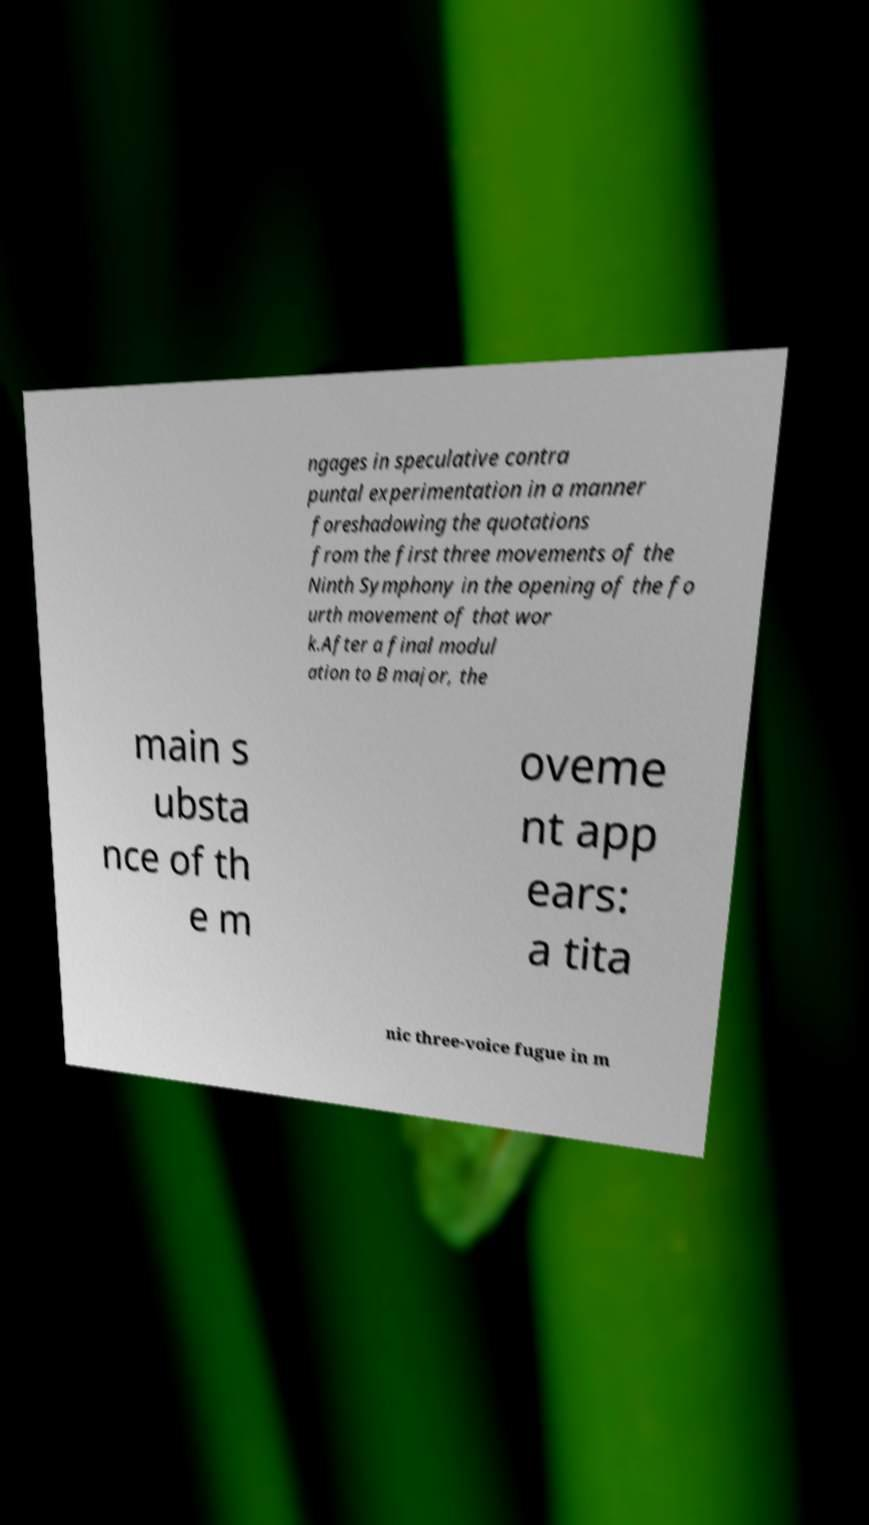Could you assist in decoding the text presented in this image and type it out clearly? ngages in speculative contra puntal experimentation in a manner foreshadowing the quotations from the first three movements of the Ninth Symphony in the opening of the fo urth movement of that wor k.After a final modul ation to B major, the main s ubsta nce of th e m oveme nt app ears: a tita nic three-voice fugue in m 